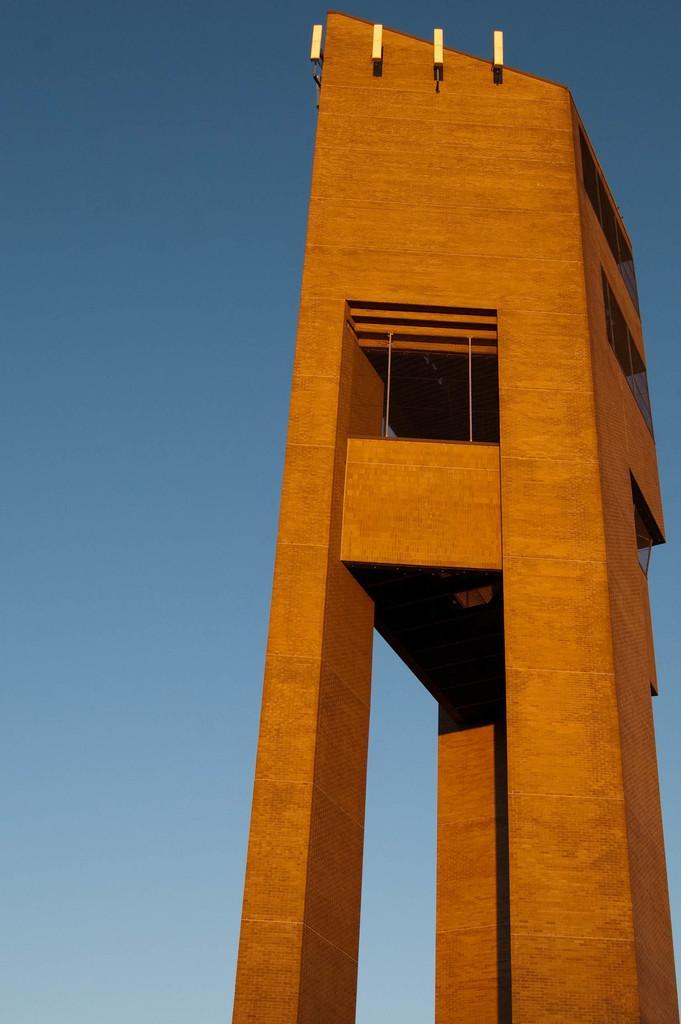Please provide a concise description of this image. In this picture, there is a building which is in brown in color. In the background, there is a sky. 